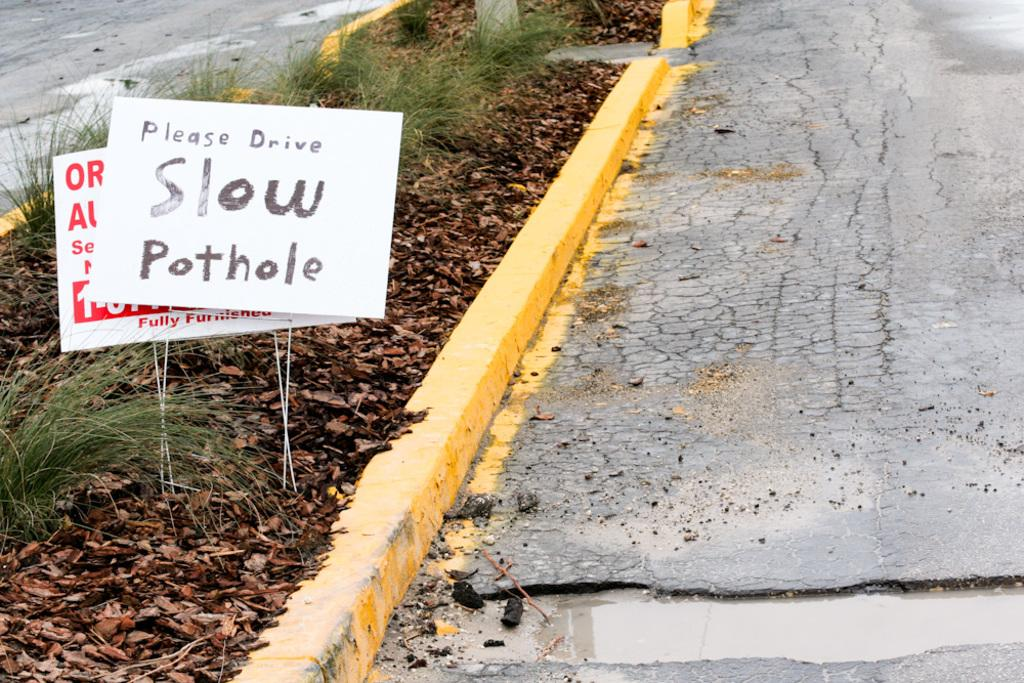What type of surface can be seen in the image? There are boards in the image, which suggests a wooden surface. What type of natural environment is visible in the image? There is grass in the image, indicating a grassy area. What can be found on the divider in the image? Dry leaves are present on a divider in the image. What is the condition of the road in the image? There is muddy water on the road in the image. How many eyes can be seen on the dolls in the image? There are no dolls present in the image, so there are no eyes to count. What type of container is used to hold arrows in the image? There is no quiver or container for arrows in the image. 